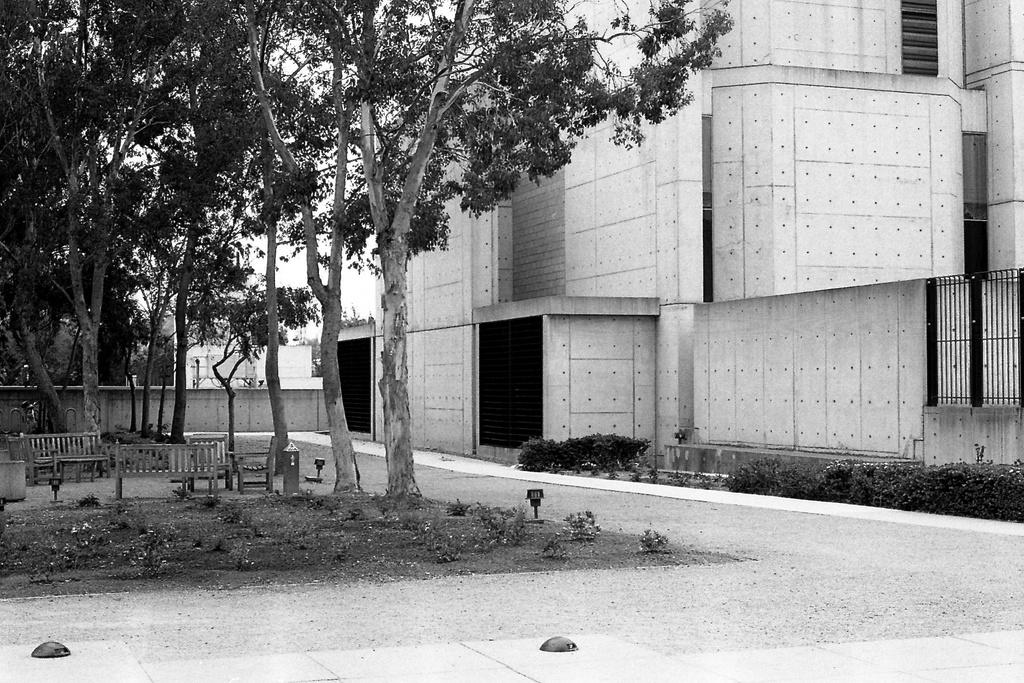What is the color scheme of the image? The image is in black and white. What type of pathway can be seen in the image? There is a road in the image. What type of seating is available in the image? There are wooden benches in the image. What type of vegetation is present in the image? Grass, plants, and trees are visible in the image. What type of structure is in the image? There is a building in the image. What architectural feature is visible in the background of the image? There is a wall in the background of the image. What part of the natural environment is visible in the background of the image? The sky is visible in the background of the image. What type of leather is used to make the science book in the image? There is no science book or leather present in the image. What emotion does the image evoke in the viewer? The image itself does not evoke an emotion, as it is a static representation of a scene. 